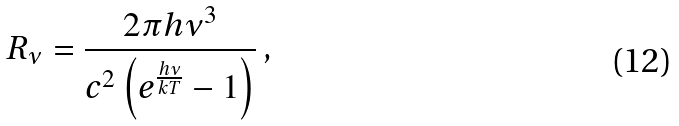Convert formula to latex. <formula><loc_0><loc_0><loc_500><loc_500>R _ { \nu } = \frac { 2 \pi h \nu ^ { 3 } } { c ^ { 2 } \left ( e ^ { \frac { h \nu } { k T } } - 1 \right ) } \, ,</formula> 